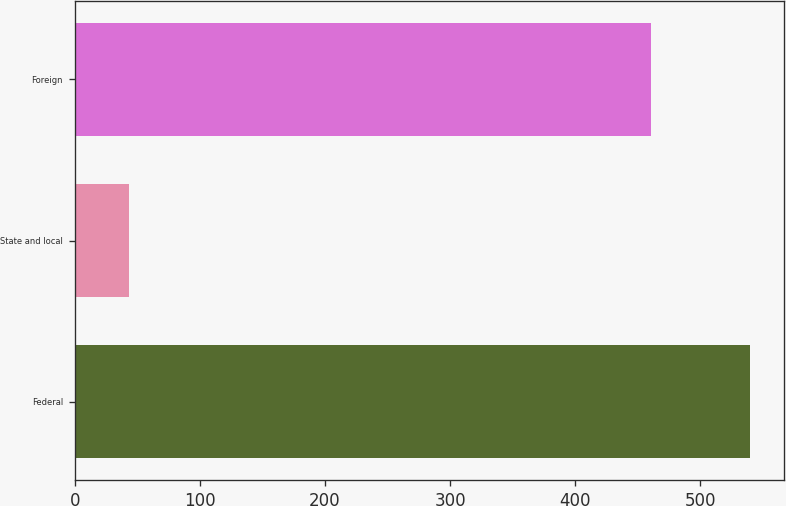<chart> <loc_0><loc_0><loc_500><loc_500><bar_chart><fcel>Federal<fcel>State and local<fcel>Foreign<nl><fcel>540<fcel>43<fcel>461<nl></chart> 